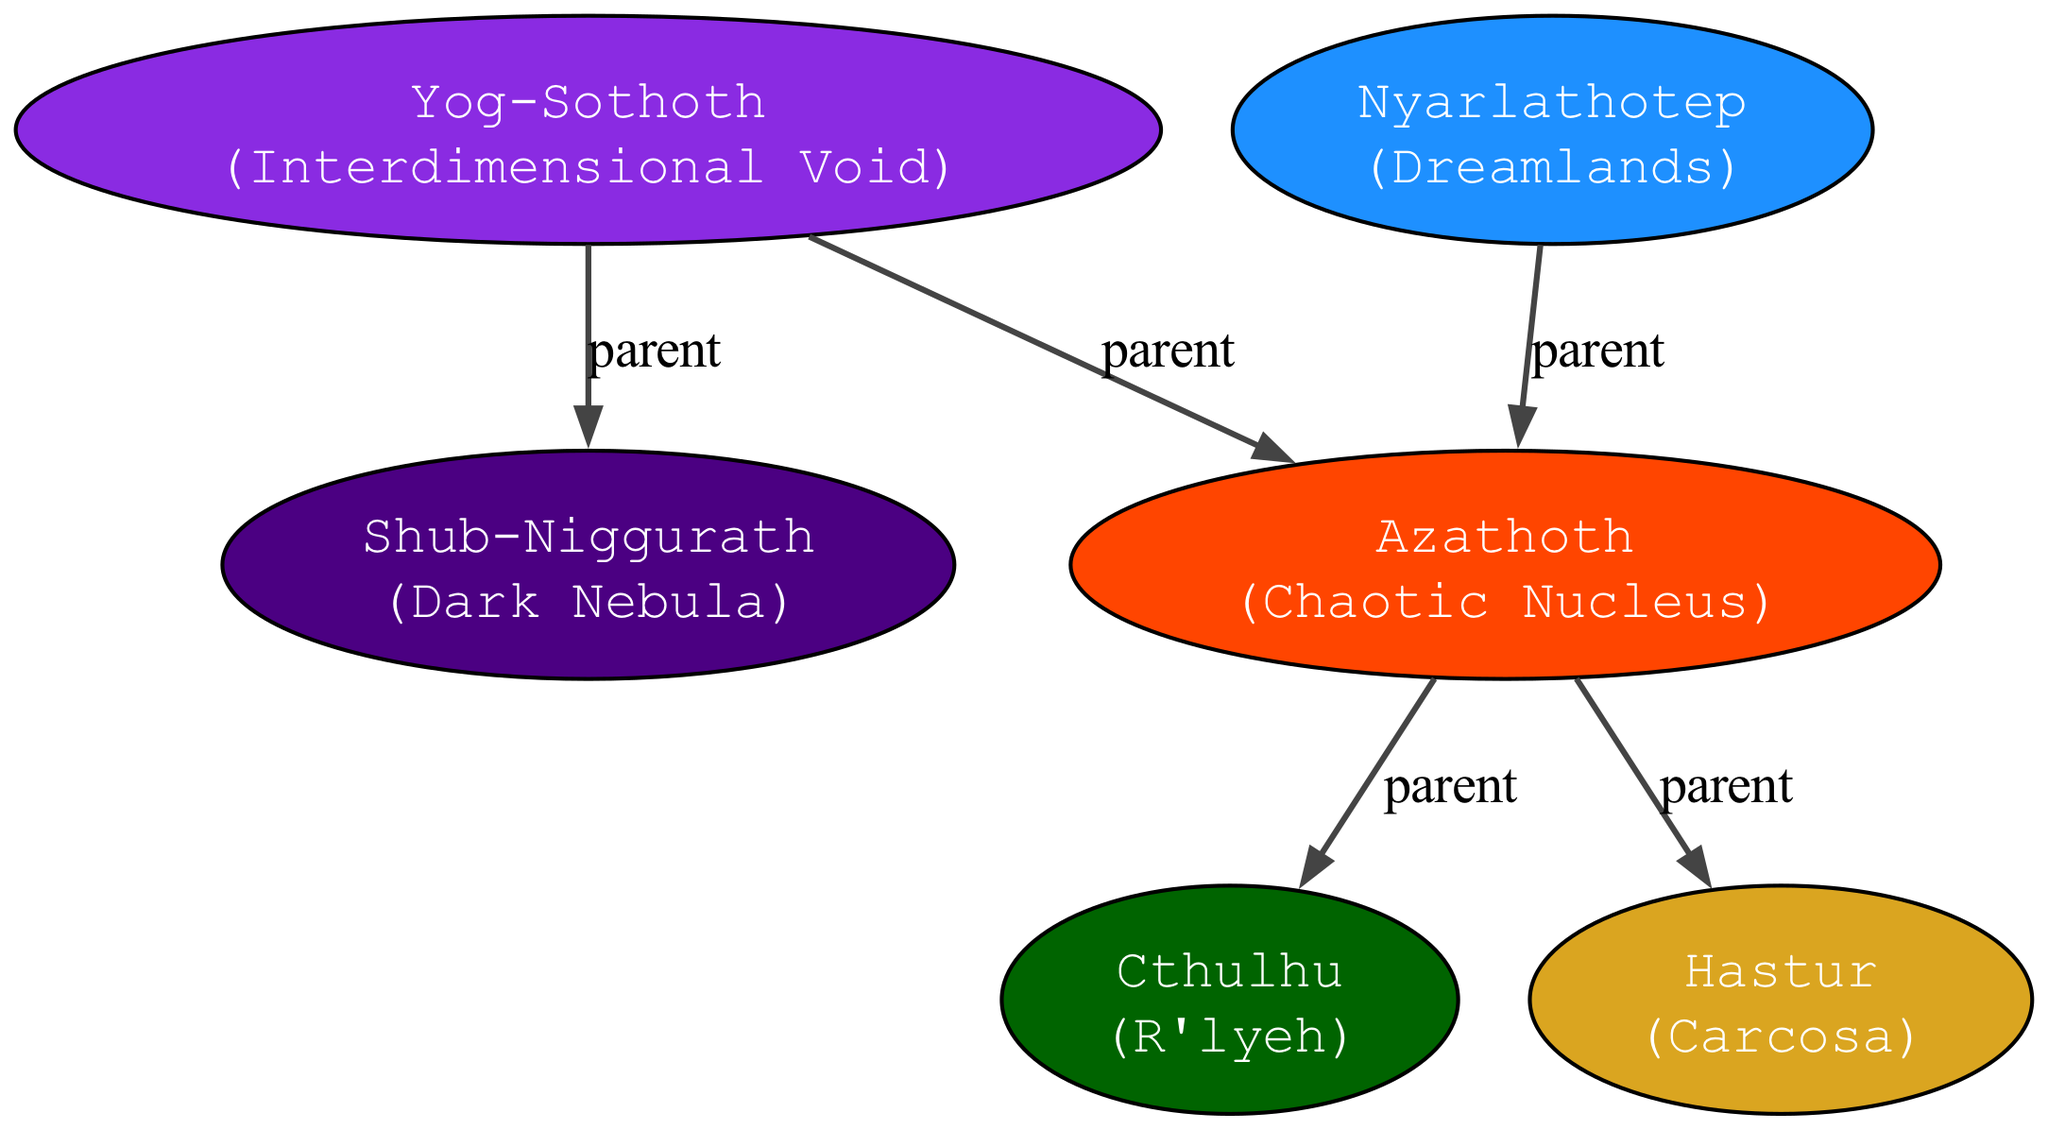What is the name of the main deity? The main deity is prominently displayed at the top of the diagram, indicated as "Azathoth."
Answer: Azathoth How many ancestors does Azathoth have? By counting the nodes representing ancestors directly connected to Azathoth, we see two: Yog-Sothoth and Nyarlathotep.
Answer: 2 Which dimension does Shub-Niggurath belong to? Shub-Niggurath is listed as an offspring of Yog-Sothoth, and its dimension is labeled as "Dark Nebula."
Answer: Dark Nebula Who is the offspring of Nyarlathotep? The diagram shows that Azathoth is the only offspring of Nyarlathotep, as indicated in the subtree under Nyarlathotep's node.
Answer: Azathoth Which deity has descendants? By examining the edges leading from the deity Azathoth, it is clear that Azathoth has two descendants: Cthulhu and Hastur.
Answer: Azathoth What is the dimension of Cthulhu? Cthulhu is connected directly to Azathoth, with its dimension marked as "R'lyeh."
Answer: R'lyeh Is Shub-Niggurath a sibling or an offspring of Azathoth? The diagram indicates that Shub-Niggurath is an offspring of Yog-Sothoth, making it a sibling of Azathoth rather than an offspring.
Answer: Sibling How many total offspring are connected to Yog-Sothoth? Upon examining the nodes underneath Yog-Sothoth, there are two offspring connected: Azathoth and Shub-Niggurath.
Answer: 2 In which dimension does the ancestor Nyarlathotep reside? The diagram displays that Nyarlathotep's dimension is labeled as "Dreamlands."
Answer: Dreamlands 